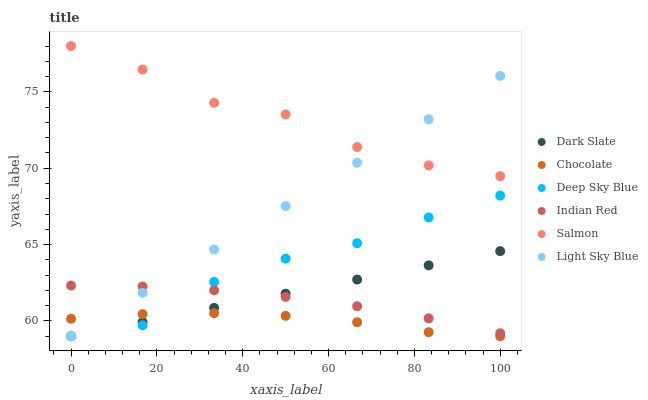Does Chocolate have the minimum area under the curve?
Answer yes or no. Yes. Does Salmon have the maximum area under the curve?
Answer yes or no. Yes. Does Salmon have the minimum area under the curve?
Answer yes or no. No. Does Chocolate have the maximum area under the curve?
Answer yes or no. No. Is Dark Slate the smoothest?
Answer yes or no. Yes. Is Salmon the roughest?
Answer yes or no. Yes. Is Chocolate the smoothest?
Answer yes or no. No. Is Chocolate the roughest?
Answer yes or no. No. Does Deep Sky Blue have the lowest value?
Answer yes or no. Yes. Does Salmon have the lowest value?
Answer yes or no. No. Does Salmon have the highest value?
Answer yes or no. Yes. Does Chocolate have the highest value?
Answer yes or no. No. Is Indian Red less than Salmon?
Answer yes or no. Yes. Is Salmon greater than Chocolate?
Answer yes or no. Yes. Does Dark Slate intersect Light Sky Blue?
Answer yes or no. Yes. Is Dark Slate less than Light Sky Blue?
Answer yes or no. No. Is Dark Slate greater than Light Sky Blue?
Answer yes or no. No. Does Indian Red intersect Salmon?
Answer yes or no. No. 